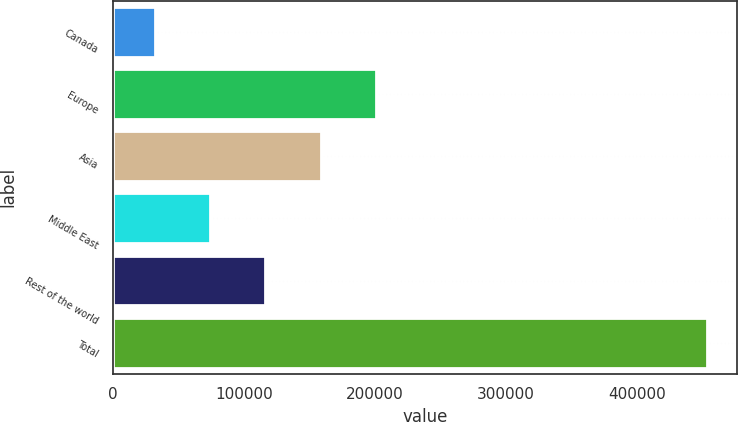Convert chart. <chart><loc_0><loc_0><loc_500><loc_500><bar_chart><fcel>Canada<fcel>Europe<fcel>Asia<fcel>Middle East<fcel>Rest of the world<fcel>Total<nl><fcel>31831<fcel>200667<fcel>158458<fcel>74039.9<fcel>116249<fcel>453920<nl></chart> 